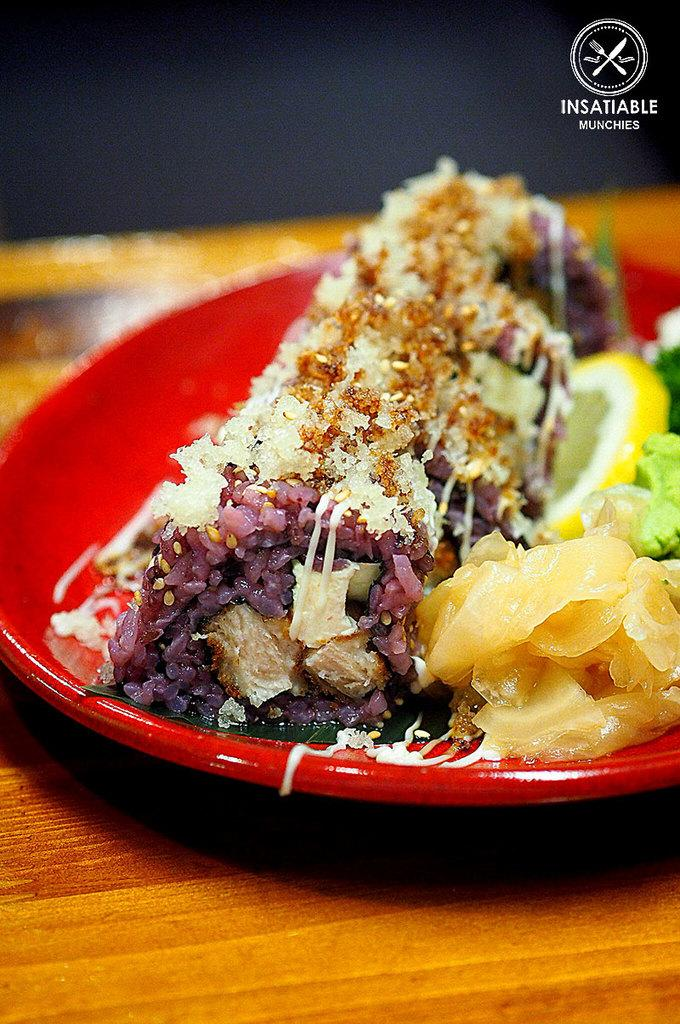What is on the table in the image? There is a plate on the table in the image. What is on the plate? There is food in the plate. Can you describe any additional details about the image? There is text and a logo in the top right corner of the image. What type of brush is being used to apply the liquid to the plate in the image? There is no brush or liquid present in the image; it only features a plate with food and text/logo in the top right corner. 